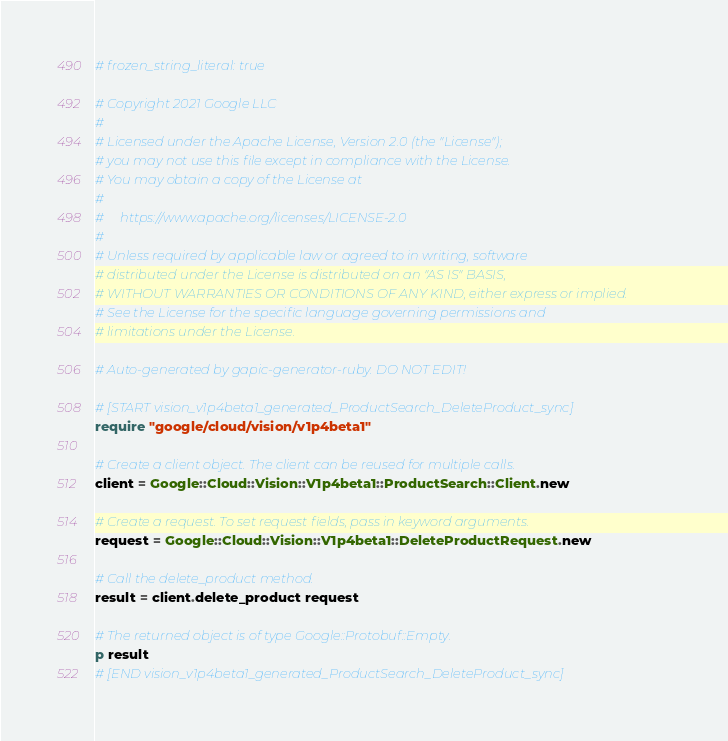Convert code to text. <code><loc_0><loc_0><loc_500><loc_500><_Ruby_># frozen_string_literal: true

# Copyright 2021 Google LLC
#
# Licensed under the Apache License, Version 2.0 (the "License");
# you may not use this file except in compliance with the License.
# You may obtain a copy of the License at
#
#     https://www.apache.org/licenses/LICENSE-2.0
#
# Unless required by applicable law or agreed to in writing, software
# distributed under the License is distributed on an "AS IS" BASIS,
# WITHOUT WARRANTIES OR CONDITIONS OF ANY KIND, either express or implied.
# See the License for the specific language governing permissions and
# limitations under the License.

# Auto-generated by gapic-generator-ruby. DO NOT EDIT!

# [START vision_v1p4beta1_generated_ProductSearch_DeleteProduct_sync]
require "google/cloud/vision/v1p4beta1"

# Create a client object. The client can be reused for multiple calls.
client = Google::Cloud::Vision::V1p4beta1::ProductSearch::Client.new

# Create a request. To set request fields, pass in keyword arguments.
request = Google::Cloud::Vision::V1p4beta1::DeleteProductRequest.new

# Call the delete_product method.
result = client.delete_product request

# The returned object is of type Google::Protobuf::Empty.
p result
# [END vision_v1p4beta1_generated_ProductSearch_DeleteProduct_sync]
</code> 